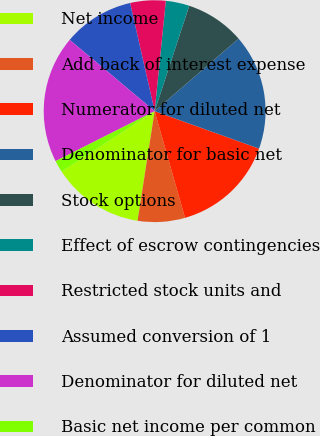Convert chart to OTSL. <chart><loc_0><loc_0><loc_500><loc_500><pie_chart><fcel>Net income<fcel>Add back of interest expense<fcel>Numerator for diluted net<fcel>Denominator for basic net<fcel>Stock options<fcel>Effect of escrow contingencies<fcel>Restricted stock units and<fcel>Assumed conversion of 1<fcel>Denominator for diluted net<fcel>Basic net income per common<nl><fcel>13.38%<fcel>6.88%<fcel>15.1%<fcel>16.82%<fcel>8.61%<fcel>3.44%<fcel>5.16%<fcel>10.33%<fcel>18.55%<fcel>1.72%<nl></chart> 